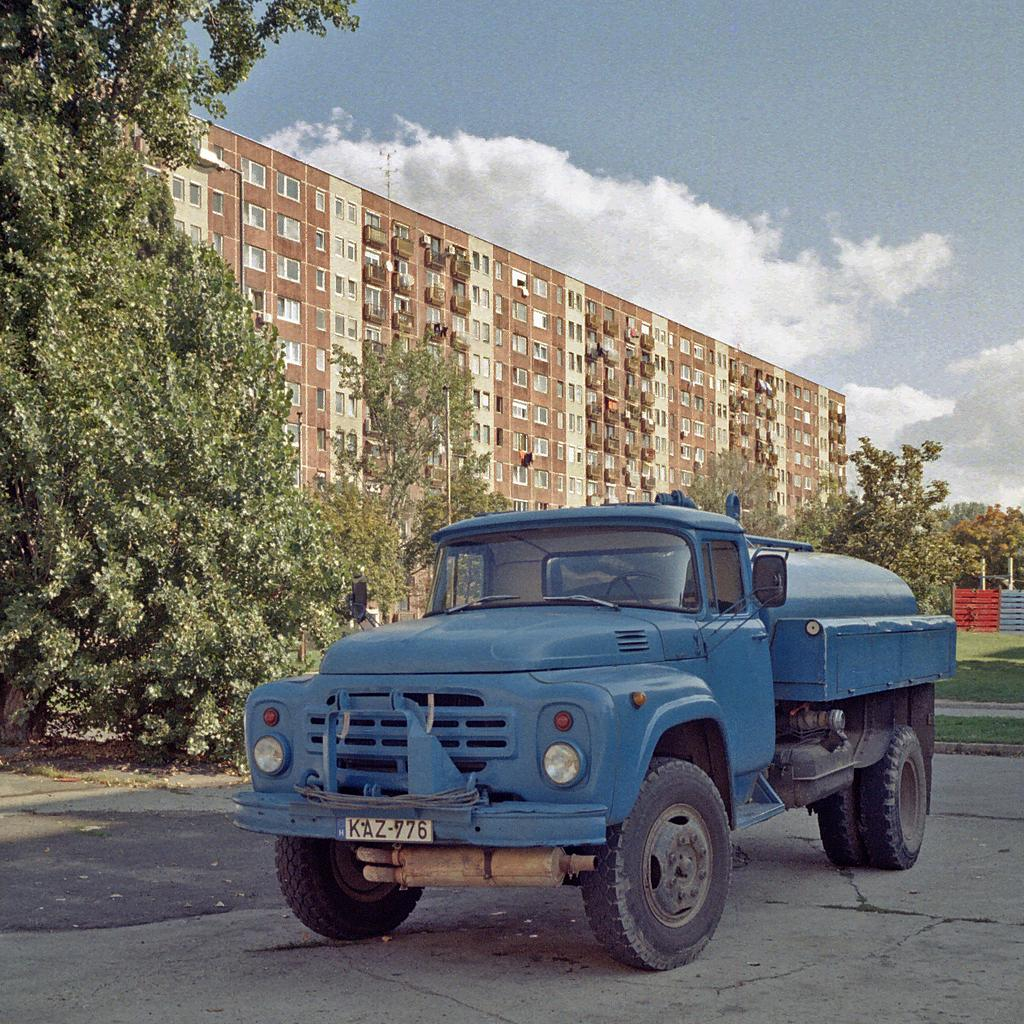What type of vehicle is in the image? There is a mini truck in the image. What color is the mini truck? The mini truck is blue. What can be seen on the left side of the image? There are trees on the left side of the image. What structures are in the middle of the image? There are big buildings in the middle of the image. How many spiders are crawling on the mini truck in the image? There are no spiders present in the image; it only features a blue mini truck and the surrounding environment. 